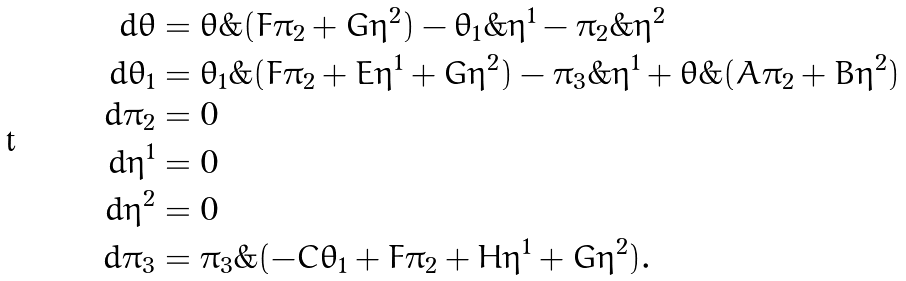<formula> <loc_0><loc_0><loc_500><loc_500>d \theta & = \theta \& ( F \pi _ { 2 } + G \eta ^ { 2 } ) - \theta _ { 1 } \& \eta ^ { 1 } - \pi _ { 2 } \& \eta ^ { 2 } \\ d \theta _ { 1 } & = \theta _ { 1 } \& ( F \pi _ { 2 } + E \eta ^ { 1 } + G \eta ^ { 2 } ) - \pi _ { 3 } \& \eta ^ { 1 } + \theta \& ( A \pi _ { 2 } + B \eta ^ { 2 } ) \\ d \pi _ { 2 } & = 0 \\ d \eta ^ { 1 } & = 0 \\ d \eta ^ { 2 } & = 0 \\ d \pi _ { 3 } & = \pi _ { 3 } \& ( - C \theta _ { 1 } + F \pi _ { 2 } + H \eta ^ { 1 } + G \eta ^ { 2 } ) .</formula> 